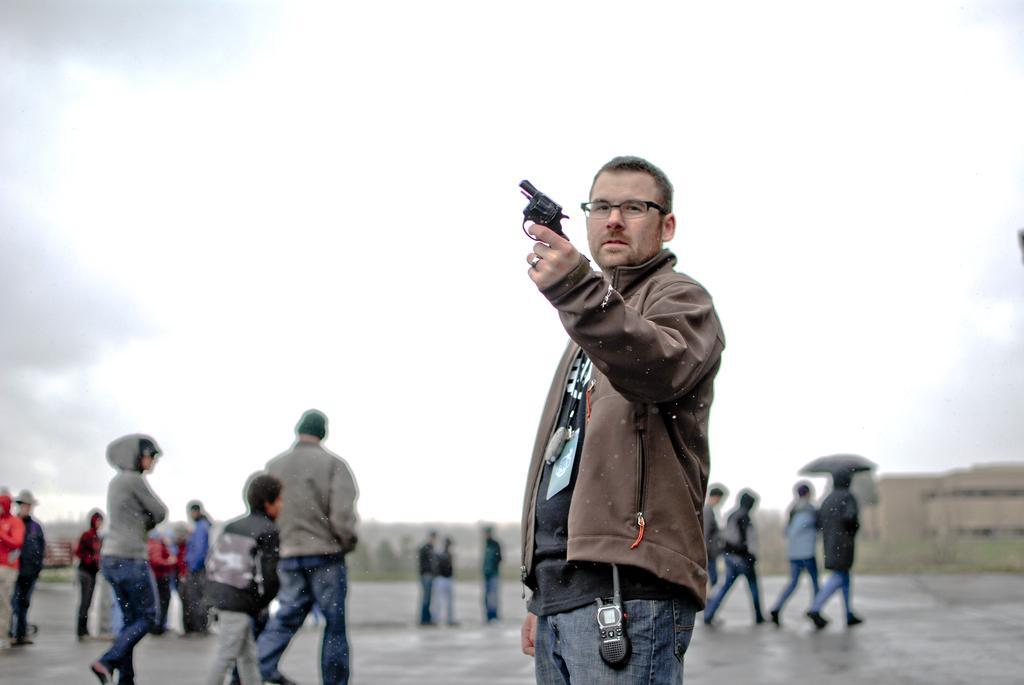Please provide a concise description of this image. In the picture I can see people among them some are walking and some are standing on the ground. The man in front of the image is holding a gun in the hand. In the background I can see the sky. The background of the image is blurred. 